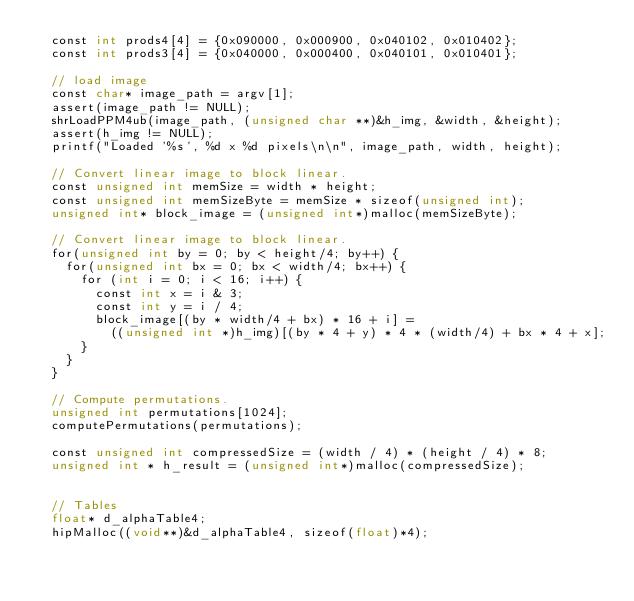Convert code to text. <code><loc_0><loc_0><loc_500><loc_500><_Cuda_>  const int prods4[4] = {0x090000, 0x000900, 0x040102, 0x010402};
  const int prods3[4] = {0x040000, 0x000400, 0x040101, 0x010401};

  // load image 
  const char* image_path = argv[1];
  assert(image_path != NULL);
  shrLoadPPM4ub(image_path, (unsigned char **)&h_img, &width, &height);
  assert(h_img != NULL);
  printf("Loaded '%s', %d x %d pixels\n\n", image_path, width, height);

  // Convert linear image to block linear. 
  const unsigned int memSize = width * height;
  const unsigned int memSizeByte = memSize * sizeof(unsigned int);
  unsigned int* block_image = (unsigned int*)malloc(memSizeByte);

  // Convert linear image to block linear. 
  for(unsigned int by = 0; by < height/4; by++) {
    for(unsigned int bx = 0; bx < width/4; bx++) {
      for (int i = 0; i < 16; i++) {
        const int x = i & 3;
        const int y = i / 4;
        block_image[(by * width/4 + bx) * 16 + i] = 
          ((unsigned int *)h_img)[(by * 4 + y) * 4 * (width/4) + bx * 4 + x];
      }
    }
  }

  // Compute permutations.
  unsigned int permutations[1024];
  computePermutations(permutations);

  const unsigned int compressedSize = (width / 4) * (height / 4) * 8;
  unsigned int * h_result = (unsigned int*)malloc(compressedSize);


  // Tables
  float* d_alphaTable4;
  hipMalloc((void**)&d_alphaTable4, sizeof(float)*4);</code> 